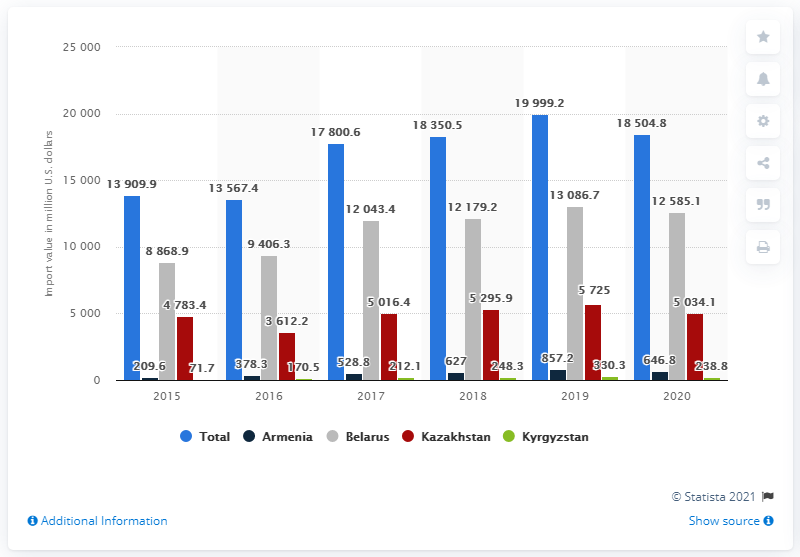Specify some key components in this picture. In the year 2016, the total value of imports for Belarus and Kazakhstan was 130,185.5. In 2020, the value of goods imported from Belarus was 12,585.1. The value of imports from Armenia in the year 2015 was 209.6 million dollars. In 2015, the value of Russian imports from the countries of the Eurasian Economic Union was 13909.9 million dollars. The highest value of goods imported from Belarus was recorded. 